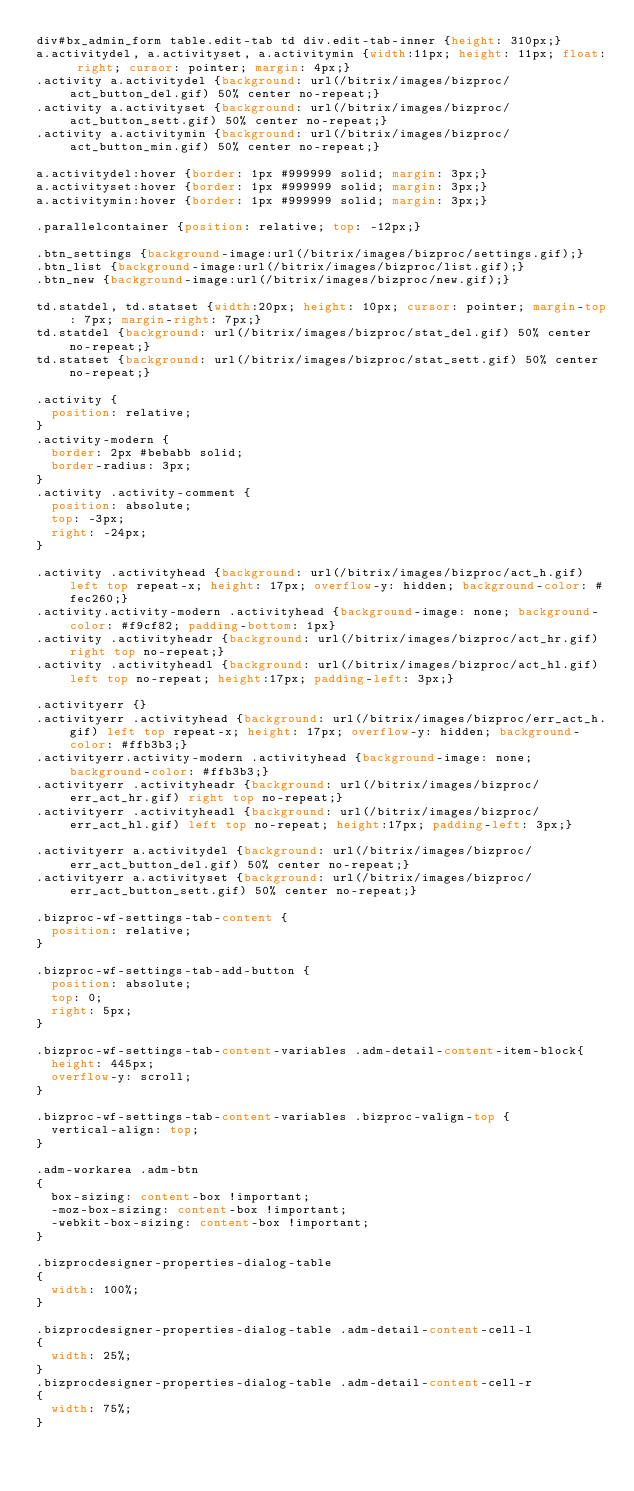<code> <loc_0><loc_0><loc_500><loc_500><_CSS_>div#bx_admin_form table.edit-tab td div.edit-tab-inner {height: 310px;}
a.activitydel, a.activityset, a.activitymin {width:11px; height: 11px; float: right; cursor: pointer; margin: 4px;}
.activity a.activitydel {background: url(/bitrix/images/bizproc/act_button_del.gif) 50% center no-repeat;}
.activity a.activityset {background: url(/bitrix/images/bizproc/act_button_sett.gif) 50% center no-repeat;}
.activity a.activitymin {background: url(/bitrix/images/bizproc/act_button_min.gif) 50% center no-repeat;}

a.activitydel:hover {border: 1px #999999 solid; margin: 3px;}
a.activityset:hover {border: 1px #999999 solid; margin: 3px;}
a.activitymin:hover {border: 1px #999999 solid; margin: 3px;}

.parallelcontainer {position: relative; top: -12px;}

.btn_settings {background-image:url(/bitrix/images/bizproc/settings.gif);}
.btn_list {background-image:url(/bitrix/images/bizproc/list.gif);}
.btn_new {background-image:url(/bitrix/images/bizproc/new.gif);}

td.statdel, td.statset {width:20px; height: 10px; cursor: pointer; margin-top: 7px; margin-right: 7px;}
td.statdel {background: url(/bitrix/images/bizproc/stat_del.gif) 50% center no-repeat;}
td.statset {background: url(/bitrix/images/bizproc/stat_sett.gif) 50% center no-repeat;}

.activity {
	position: relative;
}
.activity-modern {
	border: 2px #bebabb solid;
	border-radius: 3px;
}
.activity .activity-comment {
	position: absolute;
	top: -3px;
	right: -24px;
}

.activity .activityhead {background: url(/bitrix/images/bizproc/act_h.gif) left top repeat-x; height: 17px; overflow-y: hidden; background-color: #fec260;}
.activity.activity-modern .activityhead {background-image: none; background-color: #f9cf82; padding-bottom: 1px}
.activity .activityheadr {background: url(/bitrix/images/bizproc/act_hr.gif) right top no-repeat;}
.activity .activityheadl {background: url(/bitrix/images/bizproc/act_hl.gif) left top no-repeat; height:17px; padding-left: 3px;}

.activityerr {}
.activityerr .activityhead {background: url(/bitrix/images/bizproc/err_act_h.gif) left top repeat-x; height: 17px; overflow-y: hidden; background-color: #ffb3b3;}
.activityerr.activity-modern .activityhead {background-image: none; background-color: #ffb3b3;}
.activityerr .activityheadr {background: url(/bitrix/images/bizproc/err_act_hr.gif) right top no-repeat;}
.activityerr .activityheadl {background: url(/bitrix/images/bizproc/err_act_hl.gif) left top no-repeat; height:17px; padding-left: 3px;}

.activityerr a.activitydel {background: url(/bitrix/images/bizproc/err_act_button_del.gif) 50% center no-repeat;}
.activityerr a.activityset {background: url(/bitrix/images/bizproc/err_act_button_sett.gif) 50% center no-repeat;}

.bizproc-wf-settings-tab-content {
	position: relative;
}

.bizproc-wf-settings-tab-add-button {
	position: absolute;
	top: 0;
	right: 5px;
}

.bizproc-wf-settings-tab-content-variables .adm-detail-content-item-block{
	height: 445px;
	overflow-y: scroll;
}

.bizproc-wf-settings-tab-content-variables .bizproc-valign-top {
	vertical-align: top;
}

.adm-workarea .adm-btn
{
	box-sizing: content-box !important;
	-moz-box-sizing: content-box !important;
	-webkit-box-sizing: content-box !important;
}

.bizprocdesigner-properties-dialog-table
{
	width: 100%;
}

.bizprocdesigner-properties-dialog-table .adm-detail-content-cell-l
{
	width: 25%;
}
.bizprocdesigner-properties-dialog-table .adm-detail-content-cell-r
{
	width: 75%;
}</code> 